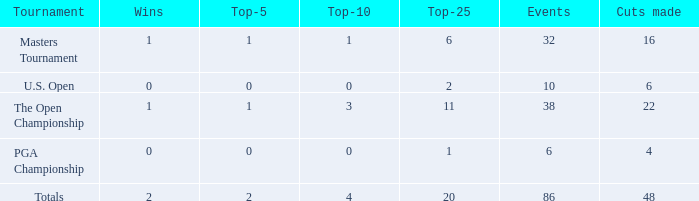Tell me the total number of events for tournament of masters tournament and top 25 less than 6 0.0. 